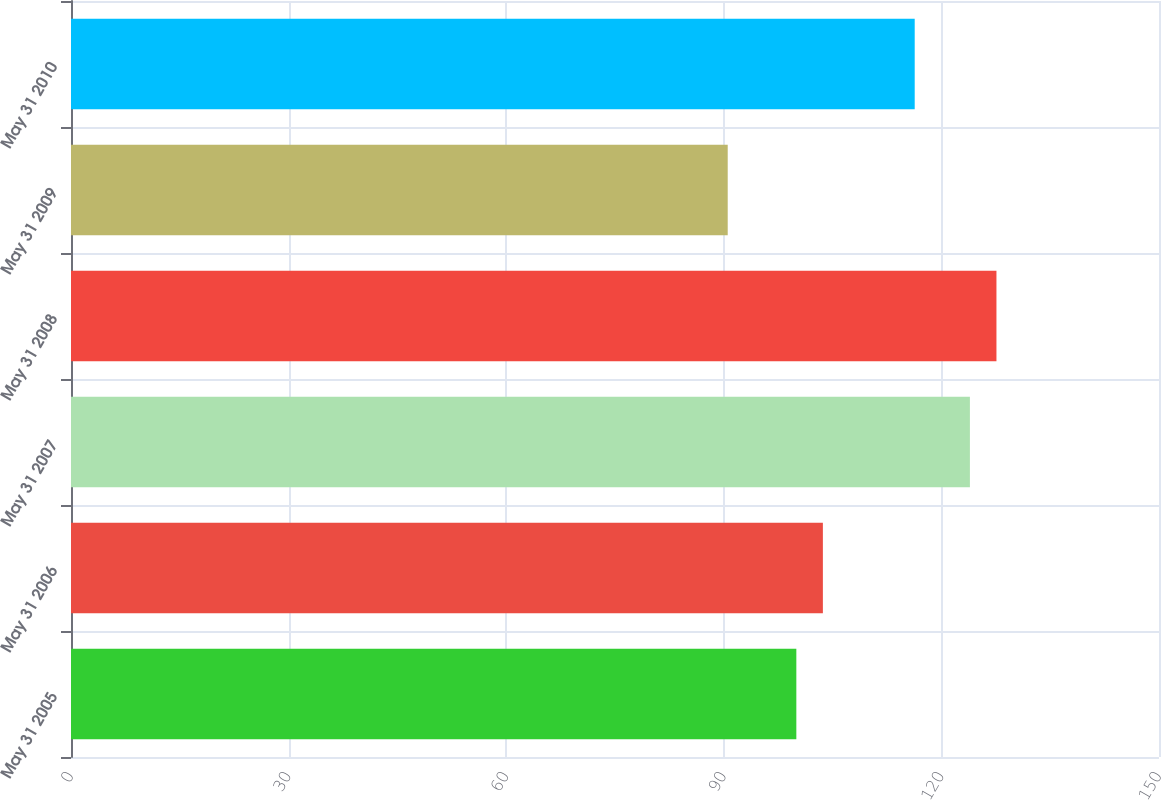Convert chart. <chart><loc_0><loc_0><loc_500><loc_500><bar_chart><fcel>May 31 2005<fcel>May 31 2006<fcel>May 31 2007<fcel>May 31 2008<fcel>May 31 2009<fcel>May 31 2010<nl><fcel>100<fcel>103.66<fcel>123.93<fcel>127.59<fcel>90.54<fcel>116.32<nl></chart> 